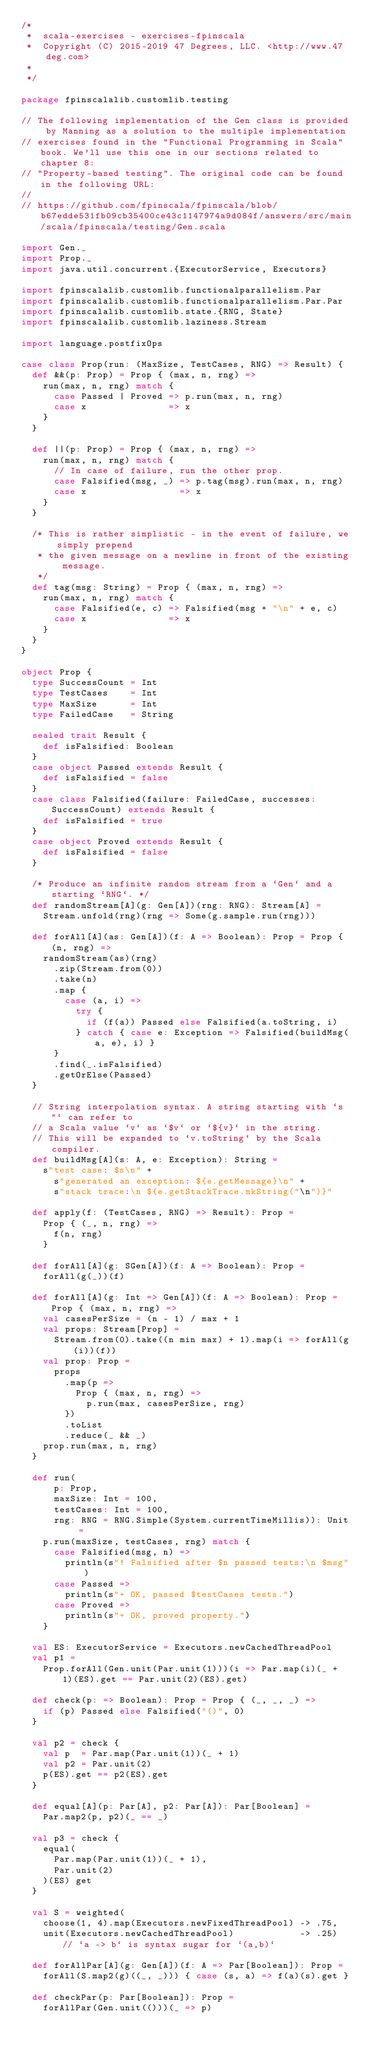Convert code to text. <code><loc_0><loc_0><loc_500><loc_500><_Scala_>/*
 *  scala-exercises - exercises-fpinscala
 *  Copyright (C) 2015-2019 47 Degrees, LLC. <http://www.47deg.com>
 *
 */

package fpinscalalib.customlib.testing

// The following implementation of the Gen class is provided by Manning as a solution to the multiple implementation
// exercises found in the "Functional Programming in Scala" book. We'll use this one in our sections related to chapter 8:
// "Property-based testing". The original code can be found in the following URL:
//
// https://github.com/fpinscala/fpinscala/blob/b67edde531fb09cb35400ce43c1147974a9d084f/answers/src/main/scala/fpinscala/testing/Gen.scala

import Gen._
import Prop._
import java.util.concurrent.{ExecutorService, Executors}

import fpinscalalib.customlib.functionalparallelism.Par
import fpinscalalib.customlib.functionalparallelism.Par.Par
import fpinscalalib.customlib.state.{RNG, State}
import fpinscalalib.customlib.laziness.Stream

import language.postfixOps

case class Prop(run: (MaxSize, TestCases, RNG) => Result) {
  def &&(p: Prop) = Prop { (max, n, rng) =>
    run(max, n, rng) match {
      case Passed | Proved => p.run(max, n, rng)
      case x               => x
    }
  }

  def ||(p: Prop) = Prop { (max, n, rng) =>
    run(max, n, rng) match {
      // In case of failure, run the other prop.
      case Falsified(msg, _) => p.tag(msg).run(max, n, rng)
      case x                 => x
    }
  }

  /* This is rather simplistic - in the event of failure, we simply prepend
   * the given message on a newline in front of the existing message.
   */
  def tag(msg: String) = Prop { (max, n, rng) =>
    run(max, n, rng) match {
      case Falsified(e, c) => Falsified(msg + "\n" + e, c)
      case x               => x
    }
  }
}

object Prop {
  type SuccessCount = Int
  type TestCases    = Int
  type MaxSize      = Int
  type FailedCase   = String

  sealed trait Result {
    def isFalsified: Boolean
  }
  case object Passed extends Result {
    def isFalsified = false
  }
  case class Falsified(failure: FailedCase, successes: SuccessCount) extends Result {
    def isFalsified = true
  }
  case object Proved extends Result {
    def isFalsified = false
  }

  /* Produce an infinite random stream from a `Gen` and a starting `RNG`. */
  def randomStream[A](g: Gen[A])(rng: RNG): Stream[A] =
    Stream.unfold(rng)(rng => Some(g.sample.run(rng)))

  def forAll[A](as: Gen[A])(f: A => Boolean): Prop = Prop { (n, rng) =>
    randomStream(as)(rng)
      .zip(Stream.from(0))
      .take(n)
      .map {
        case (a, i) =>
          try {
            if (f(a)) Passed else Falsified(a.toString, i)
          } catch { case e: Exception => Falsified(buildMsg(a, e), i) }
      }
      .find(_.isFalsified)
      .getOrElse(Passed)
  }

  // String interpolation syntax. A string starting with `s"` can refer to
  // a Scala value `v` as `$v` or `${v}` in the string.
  // This will be expanded to `v.toString` by the Scala compiler.
  def buildMsg[A](s: A, e: Exception): String =
    s"test case: $s\n" +
      s"generated an exception: ${e.getMessage}\n" +
      s"stack trace:\n ${e.getStackTrace.mkString("\n")}"

  def apply(f: (TestCases, RNG) => Result): Prop =
    Prop { (_, n, rng) =>
      f(n, rng)
    }

  def forAll[A](g: SGen[A])(f: A => Boolean): Prop =
    forAll(g(_))(f)

  def forAll[A](g: Int => Gen[A])(f: A => Boolean): Prop = Prop { (max, n, rng) =>
    val casesPerSize = (n - 1) / max + 1
    val props: Stream[Prop] =
      Stream.from(0).take((n min max) + 1).map(i => forAll(g(i))(f))
    val prop: Prop =
      props
        .map(p =>
          Prop { (max, n, rng) =>
            p.run(max, casesPerSize, rng)
        })
        .toList
        .reduce(_ && _)
    prop.run(max, n, rng)
  }

  def run(
      p: Prop,
      maxSize: Int = 100,
      testCases: Int = 100,
      rng: RNG = RNG.Simple(System.currentTimeMillis)): Unit =
    p.run(maxSize, testCases, rng) match {
      case Falsified(msg, n) =>
        println(s"! Falsified after $n passed tests:\n $msg")
      case Passed =>
        println(s"+ OK, passed $testCases tests.")
      case Proved =>
        println(s"+ OK, proved property.")
    }

  val ES: ExecutorService = Executors.newCachedThreadPool
  val p1 =
    Prop.forAll(Gen.unit(Par.unit(1)))(i => Par.map(i)(_ + 1)(ES).get == Par.unit(2)(ES).get)

  def check(p: => Boolean): Prop = Prop { (_, _, _) =>
    if (p) Passed else Falsified("()", 0)
  }

  val p2 = check {
    val p  = Par.map(Par.unit(1))(_ + 1)
    val p2 = Par.unit(2)
    p(ES).get == p2(ES).get
  }

  def equal[A](p: Par[A], p2: Par[A]): Par[Boolean] =
    Par.map2(p, p2)(_ == _)

  val p3 = check {
    equal(
      Par.map(Par.unit(1))(_ + 1),
      Par.unit(2)
    )(ES) get
  }

  val S = weighted(
    choose(1, 4).map(Executors.newFixedThreadPool) -> .75,
    unit(Executors.newCachedThreadPool)            -> .25) // `a -> b` is syntax sugar for `(a,b)`

  def forAllPar[A](g: Gen[A])(f: A => Par[Boolean]): Prop =
    forAll(S.map2(g)((_, _))) { case (s, a) => f(a)(s).get }

  def checkPar(p: Par[Boolean]): Prop =
    forAllPar(Gen.unit(()))(_ => p)
</code> 